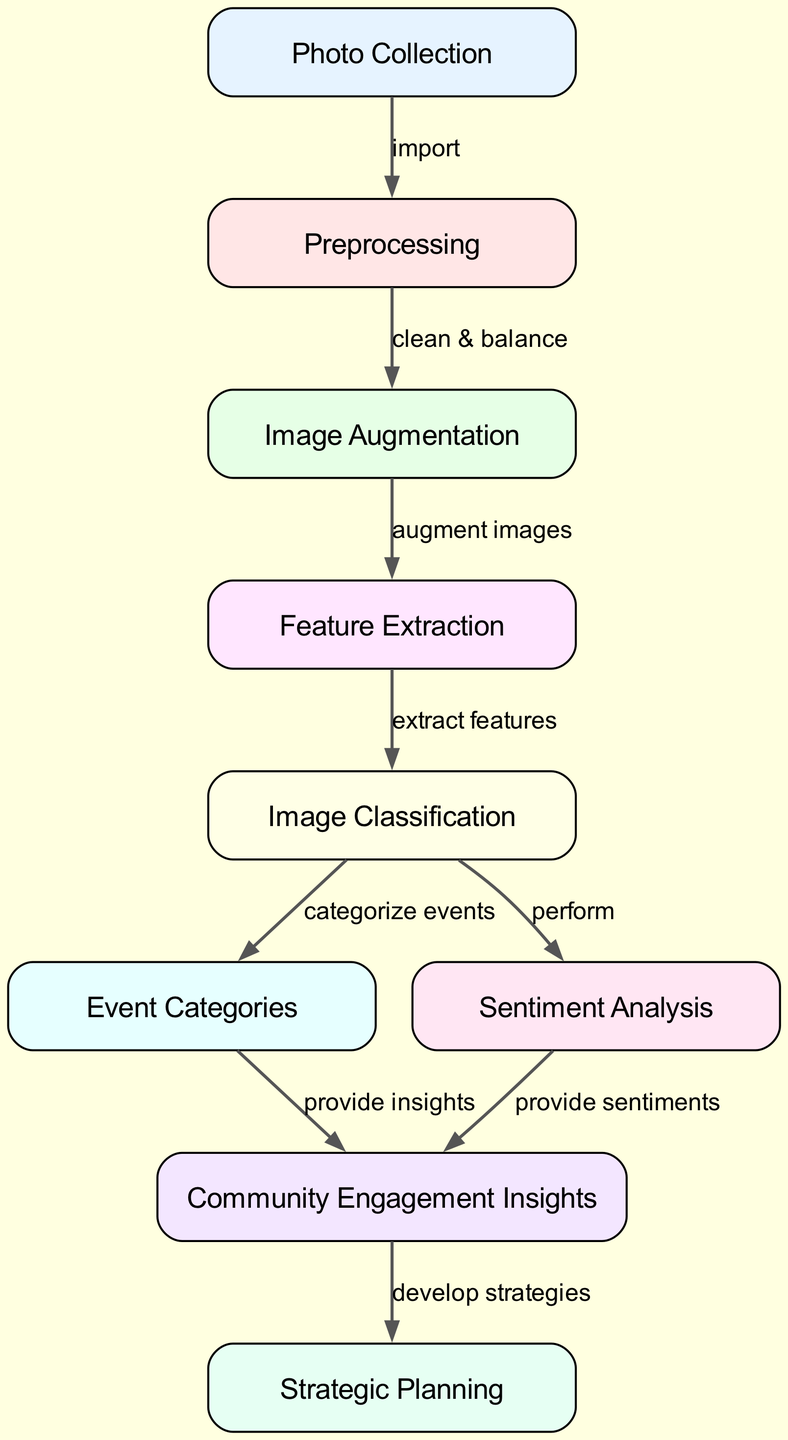What is the first step in the image processing flow? The first step is the "Photo Collection" node, which indicates that the initial action involves gathering photos.
Answer: Photo Collection How many nodes are present in the diagram? The diagram has nine nodes that represent different stages in the machine learning process for analyzing church event photos.
Answer: Nine What is the output of the "Image Classification" node? The "Image Classification" node outputs the "Event Categories" and also feeds into "Sentiment Analysis," indicating how images are categorized and analyzed for sentiments.
Answer: Event Categories and Sentiment Analysis Which nodes provide insights for community engagement? Both the "Event Categories" and "Sentiment Analysis" nodes provide insights, which are then combined in the "Community Engagement Insights" node to inform strategies.
Answer: Event Categories and Sentiment Analysis What is the relationship between "Sentiment Analysis" and "Community Engagement Insights"? The "Sentiment Analysis" node directly sends its output to the "Community Engagement Insights," contributing sentiments extracted from the analyzed photos.
Answer: Provides sentiments What process occurs after "Preprocessing"? After "Preprocessing," the next process is "Image Augmentation," which enhances the original images to improve the dataset's quality and diversity for training.
Answer: Image Augmentation Which node is directly linked to "Strategic Planning"? The "Community Engagement Insights" node is directly linked to the "Strategic Planning" node, illustrating that insights derived funnel into planning actions for better engagement strategies.
Answer: Community Engagement Insights What task does the "Feature Extraction" node perform? The "Feature Extraction" node is tasked with extracting important features from the preprocessed images to assist in the classification of those images.
Answer: Extract features Which node is responsible for balancing the dataset? The "Preprocessing" node is responsible for cleaning and balancing the dataset before proceeding with any augmentations or analysis.
Answer: Preprocessing 